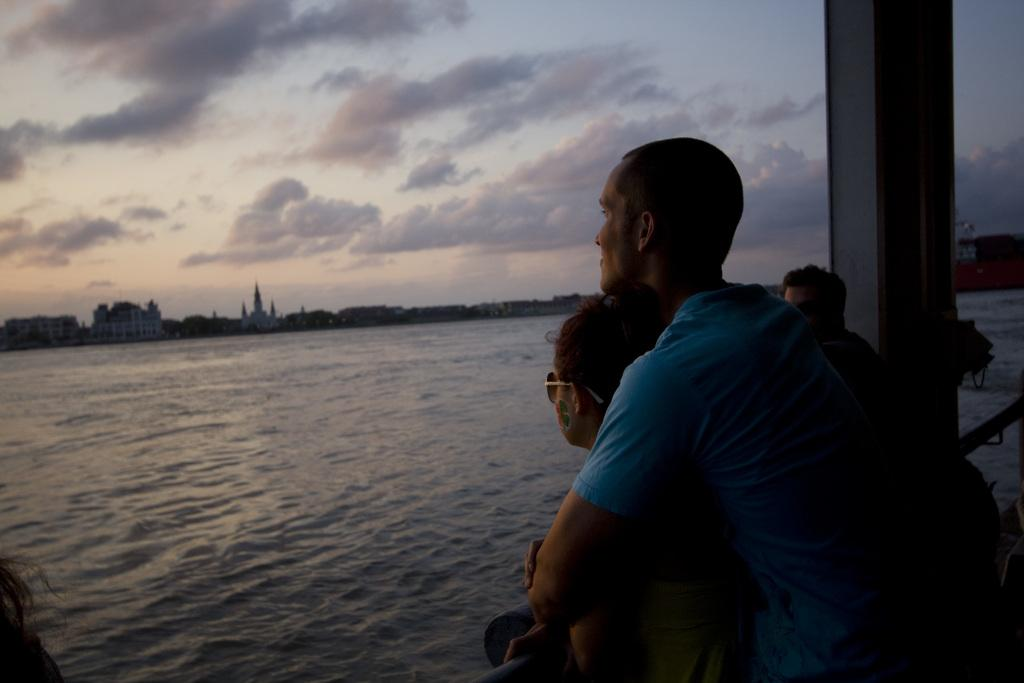What can be seen on the right side of the image in the foreground? There are people standing in the foreground of the image on the right side. What object is also present in the foreground of the image? There is a pillar in the foreground of the image. What is visible in the background of the image? Water and the sky are visible in the background of the image. What can be observed in the sky? There are clouds in the sky. Can you describe the haircut of the person standing on the right side of the image? There is no information about the haircuts of the people in the image, as the facts provided do not mention any details about their appearance. Is there a ship visible in the water in the background of the image? There is no mention of a ship in the image; only water and the sky are visible in the background. 